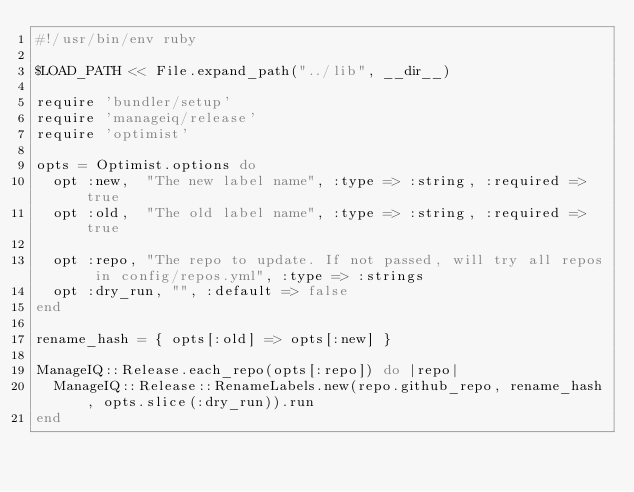Convert code to text. <code><loc_0><loc_0><loc_500><loc_500><_Ruby_>#!/usr/bin/env ruby

$LOAD_PATH << File.expand_path("../lib", __dir__)

require 'bundler/setup'
require 'manageiq/release'
require 'optimist'

opts = Optimist.options do
  opt :new,  "The new label name", :type => :string, :required => true
  opt :old,  "The old label name", :type => :string, :required => true

  opt :repo, "The repo to update. If not passed, will try all repos in config/repos.yml", :type => :strings
  opt :dry_run, "", :default => false
end

rename_hash = { opts[:old] => opts[:new] }

ManageIQ::Release.each_repo(opts[:repo]) do |repo|
  ManageIQ::Release::RenameLabels.new(repo.github_repo, rename_hash, opts.slice(:dry_run)).run
end
</code> 